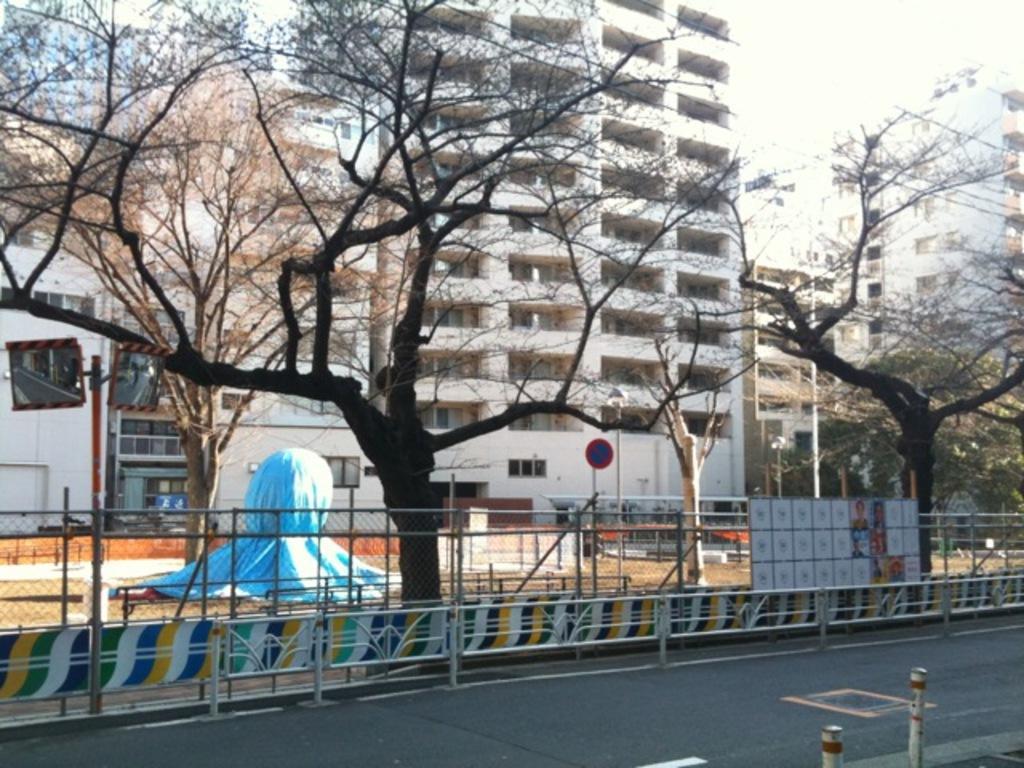Could you give a brief overview of what you see in this image? In this picture I can see buildings, trees and I can see metal fence and I can see few pictures on the board and I can see sky. 